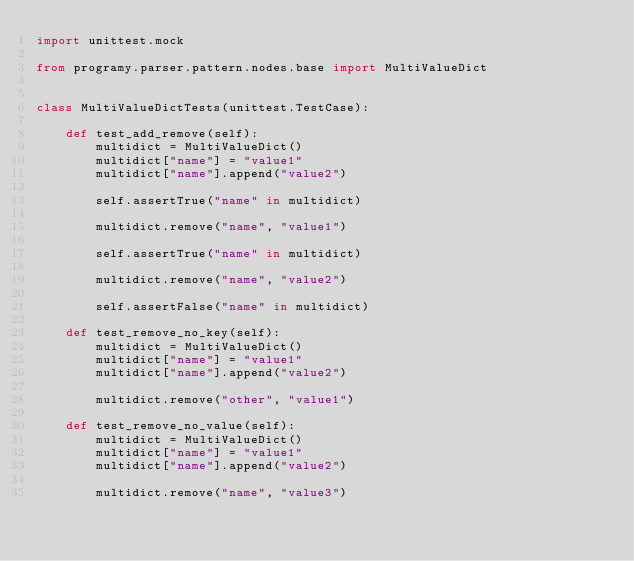Convert code to text. <code><loc_0><loc_0><loc_500><loc_500><_Python_>import unittest.mock

from programy.parser.pattern.nodes.base import MultiValueDict


class MultiValueDictTests(unittest.TestCase):

    def test_add_remove(self):
        multidict = MultiValueDict()
        multidict["name"] = "value1"
        multidict["name"].append("value2")

        self.assertTrue("name" in multidict)

        multidict.remove("name", "value1")

        self.assertTrue("name" in multidict)

        multidict.remove("name", "value2")

        self.assertFalse("name" in multidict)

    def test_remove_no_key(self):
        multidict = MultiValueDict()
        multidict["name"] = "value1"
        multidict["name"].append("value2")

        multidict.remove("other", "value1")

    def test_remove_no_value(self):
        multidict = MultiValueDict()
        multidict["name"] = "value1"
        multidict["name"].append("value2")

        multidict.remove("name", "value3")
</code> 